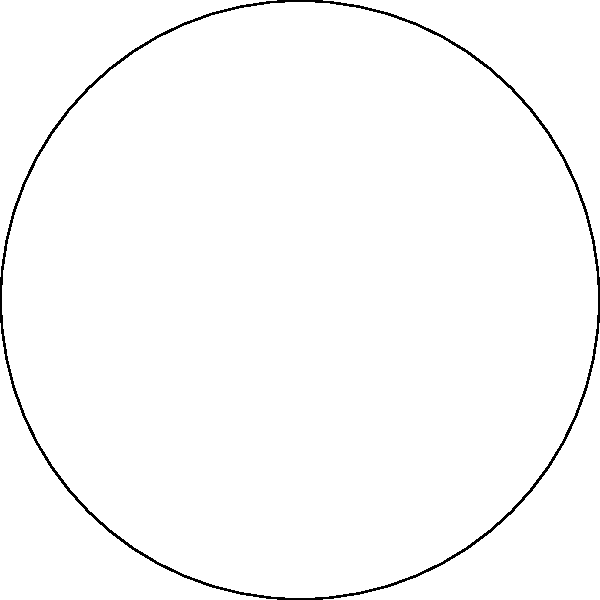Amanda Glenrose Mapena is planning a concert on a circular stage with a radius of 15 meters. The VIP section occupies $\frac{2}{3}$ of the total area, while the remaining space is for general admission. If the concert organizers charge $\$150$ per square meter for the VIP section and $\$50$ per square meter for the general admission area, how much more revenue is generated from the VIP section compared to the general admission section? Let's approach this step-by-step:

1) First, calculate the total area of the circular stage:
   $A_{total} = \pi r^2 = \pi (15^2) = 225\pi$ square meters

2) The VIP section occupies $\frac{2}{3}$ of the total area:
   $A_{VIP} = \frac{2}{3} \times 225\pi = 150\pi$ square meters

3) The general admission area is the remaining $\frac{1}{3}$:
   $A_{general} = \frac{1}{3} \times 225\pi = 75\pi$ square meters

4) Calculate the revenue from the VIP section:
   $R_{VIP} = 150\pi \times \$150 = 22,500\pi$ dollars

5) Calculate the revenue from the general admission section:
   $R_{general} = 75\pi \times \$50 = 3,750\pi$ dollars

6) Calculate the difference in revenue:
   $R_{difference} = R_{VIP} - R_{general} = 22,500\pi - 3,750\pi = 18,750\pi$ dollars

7) Simplify:
   $18,750\pi \approx 58,904.86$ dollars

Therefore, the VIP section generates approximately $\$58,904.86$ more in revenue than the general admission section.
Answer: $\$58,904.86$ 